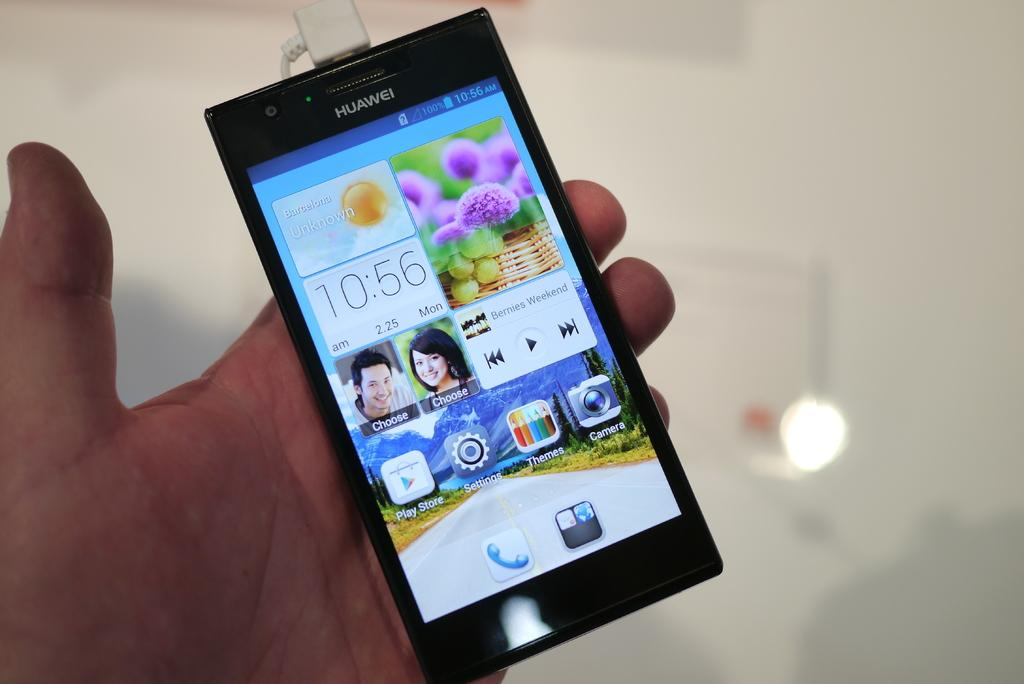<image>
Summarize the visual content of the image. A Huawei phone is being held in someones hand. 